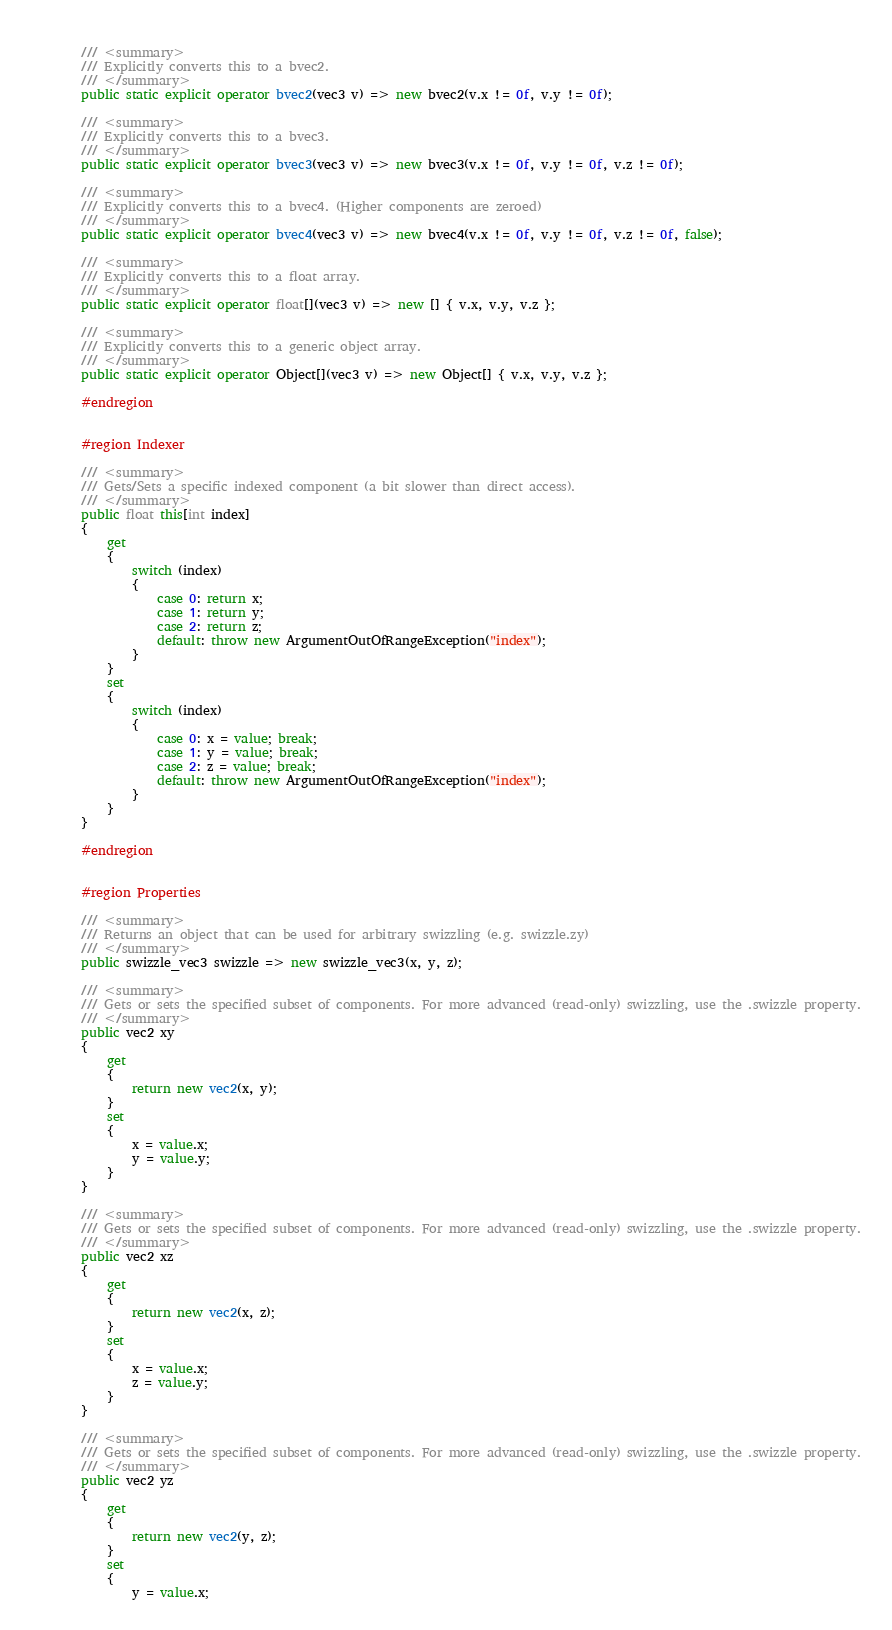<code> <loc_0><loc_0><loc_500><loc_500><_C#_>        
        /// <summary>
        /// Explicitly converts this to a bvec2.
        /// </summary>
        public static explicit operator bvec2(vec3 v) => new bvec2(v.x != 0f, v.y != 0f);
        
        /// <summary>
        /// Explicitly converts this to a bvec3.
        /// </summary>
        public static explicit operator bvec3(vec3 v) => new bvec3(v.x != 0f, v.y != 0f, v.z != 0f);
        
        /// <summary>
        /// Explicitly converts this to a bvec4. (Higher components are zeroed)
        /// </summary>
        public static explicit operator bvec4(vec3 v) => new bvec4(v.x != 0f, v.y != 0f, v.z != 0f, false);
        
        /// <summary>
        /// Explicitly converts this to a float array.
        /// </summary>
        public static explicit operator float[](vec3 v) => new [] { v.x, v.y, v.z };
        
        /// <summary>
        /// Explicitly converts this to a generic object array.
        /// </summary>
        public static explicit operator Object[](vec3 v) => new Object[] { v.x, v.y, v.z };

        #endregion


        #region Indexer
        
        /// <summary>
        /// Gets/Sets a specific indexed component (a bit slower than direct access).
        /// </summary>
        public float this[int index]
        {
            get
            {
                switch (index)
                {
                    case 0: return x;
                    case 1: return y;
                    case 2: return z;
                    default: throw new ArgumentOutOfRangeException("index");
                }
            }
            set
            {
                switch (index)
                {
                    case 0: x = value; break;
                    case 1: y = value; break;
                    case 2: z = value; break;
                    default: throw new ArgumentOutOfRangeException("index");
                }
            }
        }

        #endregion


        #region Properties
        
        /// <summary>
        /// Returns an object that can be used for arbitrary swizzling (e.g. swizzle.zy)
        /// </summary>
        public swizzle_vec3 swizzle => new swizzle_vec3(x, y, z);
        
        /// <summary>
        /// Gets or sets the specified subset of components. For more advanced (read-only) swizzling, use the .swizzle property.
        /// </summary>
        public vec2 xy
        {
            get
            {
                return new vec2(x, y);
            }
            set
            {
                x = value.x;
                y = value.y;
            }
        }
        
        /// <summary>
        /// Gets or sets the specified subset of components. For more advanced (read-only) swizzling, use the .swizzle property.
        /// </summary>
        public vec2 xz
        {
            get
            {
                return new vec2(x, z);
            }
            set
            {
                x = value.x;
                z = value.y;
            }
        }
        
        /// <summary>
        /// Gets or sets the specified subset of components. For more advanced (read-only) swizzling, use the .swizzle property.
        /// </summary>
        public vec2 yz
        {
            get
            {
                return new vec2(y, z);
            }
            set
            {
                y = value.x;</code> 